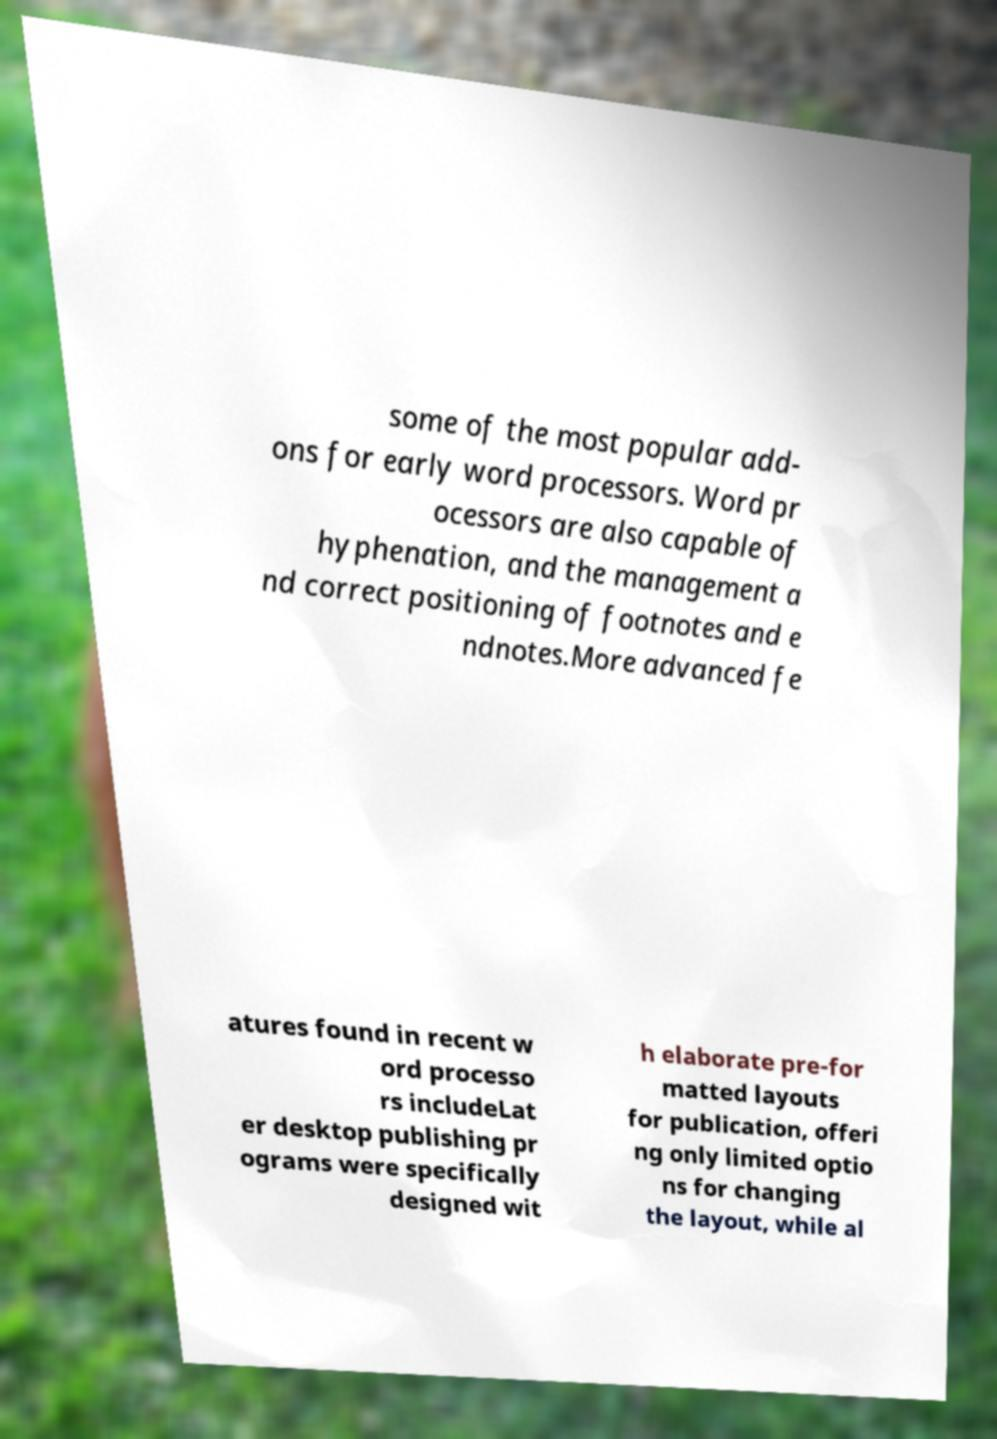Please identify and transcribe the text found in this image. some of the most popular add- ons for early word processors. Word pr ocessors are also capable of hyphenation, and the management a nd correct positioning of footnotes and e ndnotes.More advanced fe atures found in recent w ord processo rs includeLat er desktop publishing pr ograms were specifically designed wit h elaborate pre-for matted layouts for publication, offeri ng only limited optio ns for changing the layout, while al 